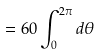<formula> <loc_0><loc_0><loc_500><loc_500>= 6 0 \int _ { 0 } ^ { 2 \pi } d \theta</formula> 